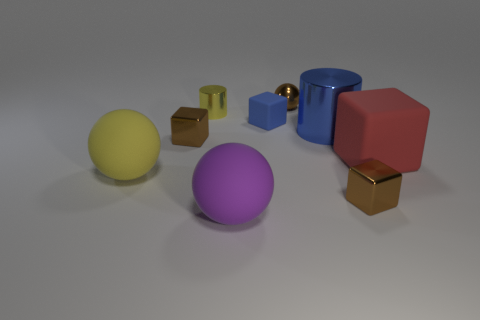Subtract 1 blocks. How many blocks are left? 3 Subtract all spheres. How many objects are left? 6 Add 7 purple spheres. How many purple spheres are left? 8 Add 3 metallic blocks. How many metallic blocks exist? 5 Subtract 0 yellow cubes. How many objects are left? 9 Subtract all yellow metal things. Subtract all small cylinders. How many objects are left? 7 